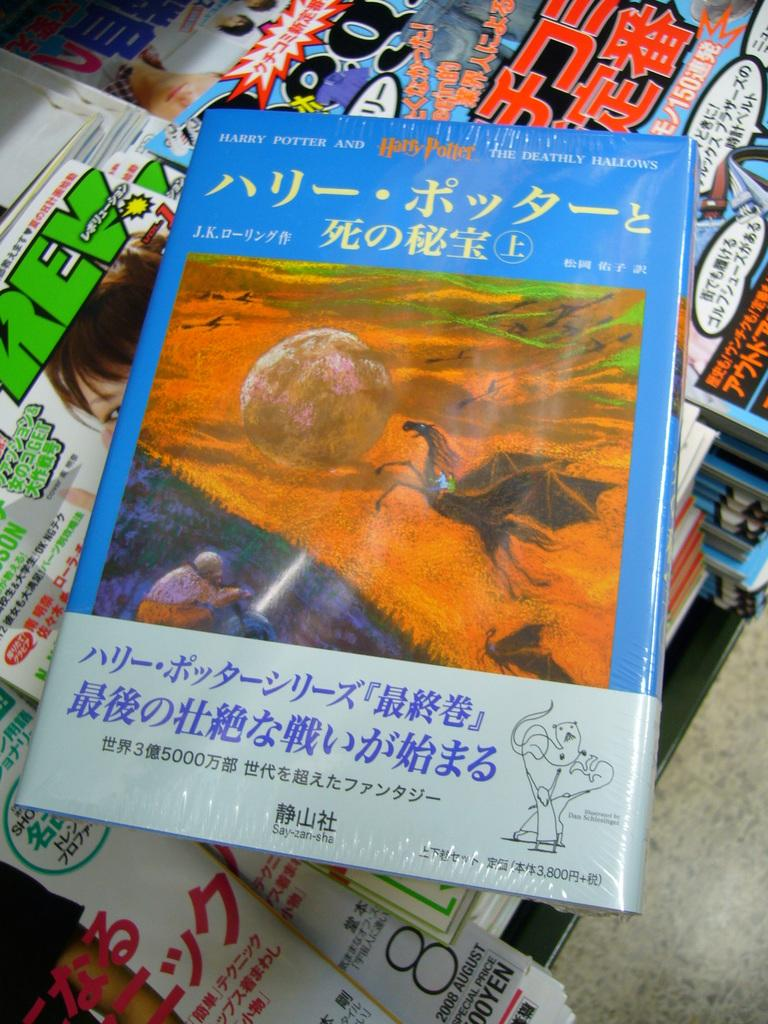Provide a one-sentence caption for the provided image. A Harry Potter book features a picture of a big boulder on the cover. 